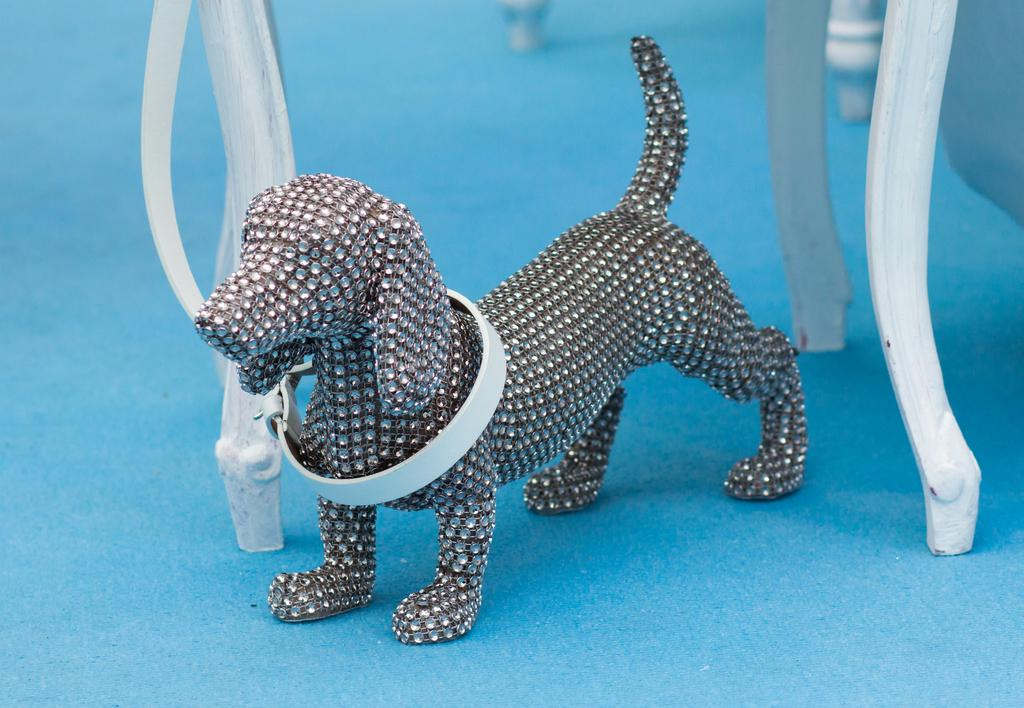What type of toy is present in the image? There is a toy dog in the image. What can be seen in the background of the image? There is a chair in the background of the image. What is the color of the chair? The chair is white in color. What type of flooring is visible in the image? There is a blue color carpet in the image. What type of collar is the toy dog wearing in the image? The toy dog is not wearing a collar in the image, as it is a toy and not a real dog. 